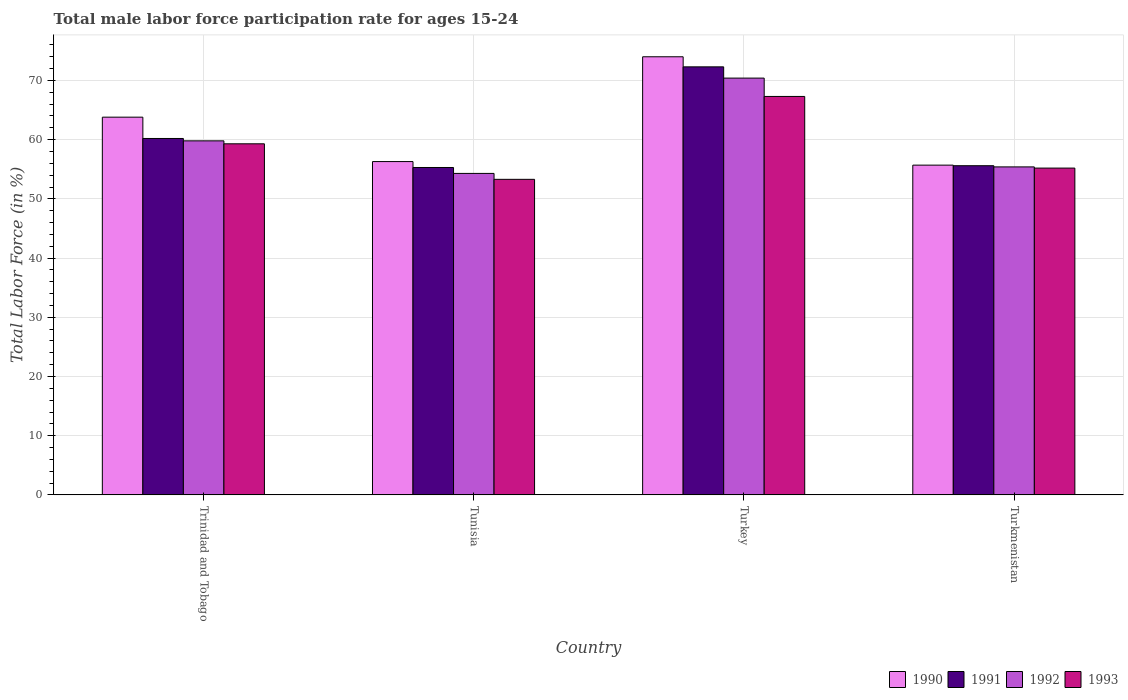How many different coloured bars are there?
Your answer should be compact. 4. How many groups of bars are there?
Your answer should be very brief. 4. Are the number of bars per tick equal to the number of legend labels?
Provide a succinct answer. Yes. How many bars are there on the 4th tick from the left?
Your response must be concise. 4. What is the label of the 1st group of bars from the left?
Ensure brevity in your answer.  Trinidad and Tobago. What is the male labor force participation rate in 1990 in Turkey?
Provide a succinct answer. 74. Across all countries, what is the maximum male labor force participation rate in 1992?
Keep it short and to the point. 70.4. Across all countries, what is the minimum male labor force participation rate in 1991?
Provide a succinct answer. 55.3. In which country was the male labor force participation rate in 1993 minimum?
Offer a terse response. Tunisia. What is the total male labor force participation rate in 1990 in the graph?
Provide a short and direct response. 249.8. What is the difference between the male labor force participation rate in 1991 in Turkey and that in Turkmenistan?
Provide a short and direct response. 16.7. What is the difference between the male labor force participation rate in 1990 in Turkey and the male labor force participation rate in 1993 in Trinidad and Tobago?
Provide a short and direct response. 14.7. What is the average male labor force participation rate in 1991 per country?
Provide a succinct answer. 60.85. What is the difference between the male labor force participation rate of/in 1991 and male labor force participation rate of/in 1993 in Turkey?
Your answer should be compact. 5. In how many countries, is the male labor force participation rate in 1992 greater than 72 %?
Keep it short and to the point. 0. What is the ratio of the male labor force participation rate in 1991 in Trinidad and Tobago to that in Turkmenistan?
Offer a terse response. 1.08. Is the difference between the male labor force participation rate in 1991 in Trinidad and Tobago and Tunisia greater than the difference between the male labor force participation rate in 1993 in Trinidad and Tobago and Tunisia?
Ensure brevity in your answer.  No. What is the difference between the highest and the second highest male labor force participation rate in 1993?
Ensure brevity in your answer.  -8. What is the difference between the highest and the lowest male labor force participation rate in 1990?
Your answer should be very brief. 18.3. In how many countries, is the male labor force participation rate in 1993 greater than the average male labor force participation rate in 1993 taken over all countries?
Give a very brief answer. 2. Is the sum of the male labor force participation rate in 1993 in Trinidad and Tobago and Turkmenistan greater than the maximum male labor force participation rate in 1991 across all countries?
Provide a succinct answer. Yes. What does the 1st bar from the left in Turkmenistan represents?
Your answer should be compact. 1990. Is it the case that in every country, the sum of the male labor force participation rate in 1991 and male labor force participation rate in 1990 is greater than the male labor force participation rate in 1992?
Your answer should be compact. Yes. Are all the bars in the graph horizontal?
Provide a short and direct response. No. Are the values on the major ticks of Y-axis written in scientific E-notation?
Provide a short and direct response. No. Does the graph contain grids?
Keep it short and to the point. Yes. How many legend labels are there?
Provide a succinct answer. 4. What is the title of the graph?
Your response must be concise. Total male labor force participation rate for ages 15-24. What is the label or title of the Y-axis?
Your answer should be very brief. Total Labor Force (in %). What is the Total Labor Force (in %) of 1990 in Trinidad and Tobago?
Keep it short and to the point. 63.8. What is the Total Labor Force (in %) of 1991 in Trinidad and Tobago?
Offer a terse response. 60.2. What is the Total Labor Force (in %) of 1992 in Trinidad and Tobago?
Make the answer very short. 59.8. What is the Total Labor Force (in %) in 1993 in Trinidad and Tobago?
Offer a terse response. 59.3. What is the Total Labor Force (in %) of 1990 in Tunisia?
Your response must be concise. 56.3. What is the Total Labor Force (in %) in 1991 in Tunisia?
Your answer should be compact. 55.3. What is the Total Labor Force (in %) of 1992 in Tunisia?
Make the answer very short. 54.3. What is the Total Labor Force (in %) in 1993 in Tunisia?
Ensure brevity in your answer.  53.3. What is the Total Labor Force (in %) of 1991 in Turkey?
Give a very brief answer. 72.3. What is the Total Labor Force (in %) in 1992 in Turkey?
Provide a succinct answer. 70.4. What is the Total Labor Force (in %) in 1993 in Turkey?
Ensure brevity in your answer.  67.3. What is the Total Labor Force (in %) in 1990 in Turkmenistan?
Offer a terse response. 55.7. What is the Total Labor Force (in %) of 1991 in Turkmenistan?
Offer a very short reply. 55.6. What is the Total Labor Force (in %) in 1992 in Turkmenistan?
Offer a very short reply. 55.4. What is the Total Labor Force (in %) in 1993 in Turkmenistan?
Make the answer very short. 55.2. Across all countries, what is the maximum Total Labor Force (in %) in 1991?
Provide a short and direct response. 72.3. Across all countries, what is the maximum Total Labor Force (in %) in 1992?
Ensure brevity in your answer.  70.4. Across all countries, what is the maximum Total Labor Force (in %) in 1993?
Provide a short and direct response. 67.3. Across all countries, what is the minimum Total Labor Force (in %) of 1990?
Give a very brief answer. 55.7. Across all countries, what is the minimum Total Labor Force (in %) in 1991?
Give a very brief answer. 55.3. Across all countries, what is the minimum Total Labor Force (in %) of 1992?
Offer a very short reply. 54.3. Across all countries, what is the minimum Total Labor Force (in %) of 1993?
Offer a very short reply. 53.3. What is the total Total Labor Force (in %) in 1990 in the graph?
Give a very brief answer. 249.8. What is the total Total Labor Force (in %) of 1991 in the graph?
Make the answer very short. 243.4. What is the total Total Labor Force (in %) in 1992 in the graph?
Ensure brevity in your answer.  239.9. What is the total Total Labor Force (in %) in 1993 in the graph?
Ensure brevity in your answer.  235.1. What is the difference between the Total Labor Force (in %) in 1993 in Trinidad and Tobago and that in Tunisia?
Provide a succinct answer. 6. What is the difference between the Total Labor Force (in %) of 1990 in Trinidad and Tobago and that in Turkey?
Keep it short and to the point. -10.2. What is the difference between the Total Labor Force (in %) of 1991 in Trinidad and Tobago and that in Turkey?
Your answer should be compact. -12.1. What is the difference between the Total Labor Force (in %) of 1993 in Trinidad and Tobago and that in Turkey?
Keep it short and to the point. -8. What is the difference between the Total Labor Force (in %) in 1990 in Trinidad and Tobago and that in Turkmenistan?
Make the answer very short. 8.1. What is the difference between the Total Labor Force (in %) in 1991 in Trinidad and Tobago and that in Turkmenistan?
Make the answer very short. 4.6. What is the difference between the Total Labor Force (in %) of 1992 in Trinidad and Tobago and that in Turkmenistan?
Give a very brief answer. 4.4. What is the difference between the Total Labor Force (in %) in 1990 in Tunisia and that in Turkey?
Your answer should be compact. -17.7. What is the difference between the Total Labor Force (in %) in 1992 in Tunisia and that in Turkey?
Your answer should be very brief. -16.1. What is the difference between the Total Labor Force (in %) in 1993 in Tunisia and that in Turkey?
Your answer should be very brief. -14. What is the difference between the Total Labor Force (in %) of 1992 in Tunisia and that in Turkmenistan?
Provide a short and direct response. -1.1. What is the difference between the Total Labor Force (in %) of 1990 in Turkey and that in Turkmenistan?
Your answer should be very brief. 18.3. What is the difference between the Total Labor Force (in %) of 1991 in Turkey and that in Turkmenistan?
Provide a succinct answer. 16.7. What is the difference between the Total Labor Force (in %) of 1992 in Turkey and that in Turkmenistan?
Make the answer very short. 15. What is the difference between the Total Labor Force (in %) in 1990 in Trinidad and Tobago and the Total Labor Force (in %) in 1993 in Tunisia?
Provide a succinct answer. 10.5. What is the difference between the Total Labor Force (in %) in 1990 in Trinidad and Tobago and the Total Labor Force (in %) in 1992 in Turkey?
Provide a succinct answer. -6.6. What is the difference between the Total Labor Force (in %) of 1991 in Trinidad and Tobago and the Total Labor Force (in %) of 1992 in Turkey?
Provide a succinct answer. -10.2. What is the difference between the Total Labor Force (in %) in 1991 in Trinidad and Tobago and the Total Labor Force (in %) in 1993 in Turkey?
Keep it short and to the point. -7.1. What is the difference between the Total Labor Force (in %) in 1992 in Trinidad and Tobago and the Total Labor Force (in %) in 1993 in Turkey?
Offer a very short reply. -7.5. What is the difference between the Total Labor Force (in %) in 1990 in Trinidad and Tobago and the Total Labor Force (in %) in 1992 in Turkmenistan?
Provide a succinct answer. 8.4. What is the difference between the Total Labor Force (in %) of 1990 in Trinidad and Tobago and the Total Labor Force (in %) of 1993 in Turkmenistan?
Make the answer very short. 8.6. What is the difference between the Total Labor Force (in %) of 1991 in Trinidad and Tobago and the Total Labor Force (in %) of 1993 in Turkmenistan?
Your answer should be compact. 5. What is the difference between the Total Labor Force (in %) in 1992 in Trinidad and Tobago and the Total Labor Force (in %) in 1993 in Turkmenistan?
Your response must be concise. 4.6. What is the difference between the Total Labor Force (in %) in 1990 in Tunisia and the Total Labor Force (in %) in 1992 in Turkey?
Your answer should be compact. -14.1. What is the difference between the Total Labor Force (in %) of 1990 in Tunisia and the Total Labor Force (in %) of 1993 in Turkey?
Offer a very short reply. -11. What is the difference between the Total Labor Force (in %) of 1991 in Tunisia and the Total Labor Force (in %) of 1992 in Turkey?
Offer a terse response. -15.1. What is the difference between the Total Labor Force (in %) of 1991 in Tunisia and the Total Labor Force (in %) of 1993 in Turkey?
Offer a terse response. -12. What is the difference between the Total Labor Force (in %) in 1992 in Tunisia and the Total Labor Force (in %) in 1993 in Turkey?
Give a very brief answer. -13. What is the difference between the Total Labor Force (in %) in 1991 in Tunisia and the Total Labor Force (in %) in 1992 in Turkmenistan?
Ensure brevity in your answer.  -0.1. What is the difference between the Total Labor Force (in %) in 1990 in Turkey and the Total Labor Force (in %) in 1992 in Turkmenistan?
Make the answer very short. 18.6. What is the difference between the Total Labor Force (in %) of 1990 in Turkey and the Total Labor Force (in %) of 1993 in Turkmenistan?
Make the answer very short. 18.8. What is the difference between the Total Labor Force (in %) of 1991 in Turkey and the Total Labor Force (in %) of 1992 in Turkmenistan?
Provide a short and direct response. 16.9. What is the difference between the Total Labor Force (in %) in 1991 in Turkey and the Total Labor Force (in %) in 1993 in Turkmenistan?
Give a very brief answer. 17.1. What is the average Total Labor Force (in %) in 1990 per country?
Offer a very short reply. 62.45. What is the average Total Labor Force (in %) in 1991 per country?
Your response must be concise. 60.85. What is the average Total Labor Force (in %) in 1992 per country?
Your response must be concise. 59.98. What is the average Total Labor Force (in %) in 1993 per country?
Provide a short and direct response. 58.77. What is the difference between the Total Labor Force (in %) in 1990 and Total Labor Force (in %) in 1991 in Trinidad and Tobago?
Provide a short and direct response. 3.6. What is the difference between the Total Labor Force (in %) of 1990 and Total Labor Force (in %) of 1992 in Trinidad and Tobago?
Offer a very short reply. 4. What is the difference between the Total Labor Force (in %) of 1991 and Total Labor Force (in %) of 1992 in Trinidad and Tobago?
Offer a terse response. 0.4. What is the difference between the Total Labor Force (in %) in 1990 and Total Labor Force (in %) in 1991 in Tunisia?
Provide a short and direct response. 1. What is the difference between the Total Labor Force (in %) of 1990 and Total Labor Force (in %) of 1993 in Tunisia?
Your answer should be very brief. 3. What is the difference between the Total Labor Force (in %) of 1991 and Total Labor Force (in %) of 1993 in Tunisia?
Offer a terse response. 2. What is the difference between the Total Labor Force (in %) in 1992 and Total Labor Force (in %) in 1993 in Tunisia?
Provide a short and direct response. 1. What is the difference between the Total Labor Force (in %) in 1990 and Total Labor Force (in %) in 1991 in Turkey?
Your response must be concise. 1.7. What is the difference between the Total Labor Force (in %) of 1990 and Total Labor Force (in %) of 1992 in Turkey?
Ensure brevity in your answer.  3.6. What is the difference between the Total Labor Force (in %) of 1990 and Total Labor Force (in %) of 1993 in Turkey?
Give a very brief answer. 6.7. What is the difference between the Total Labor Force (in %) of 1991 and Total Labor Force (in %) of 1993 in Turkey?
Keep it short and to the point. 5. What is the difference between the Total Labor Force (in %) in 1992 and Total Labor Force (in %) in 1993 in Turkey?
Keep it short and to the point. 3.1. What is the difference between the Total Labor Force (in %) in 1990 and Total Labor Force (in %) in 1991 in Turkmenistan?
Your answer should be compact. 0.1. What is the difference between the Total Labor Force (in %) in 1991 and Total Labor Force (in %) in 1992 in Turkmenistan?
Ensure brevity in your answer.  0.2. What is the difference between the Total Labor Force (in %) of 1992 and Total Labor Force (in %) of 1993 in Turkmenistan?
Ensure brevity in your answer.  0.2. What is the ratio of the Total Labor Force (in %) of 1990 in Trinidad and Tobago to that in Tunisia?
Your answer should be very brief. 1.13. What is the ratio of the Total Labor Force (in %) of 1991 in Trinidad and Tobago to that in Tunisia?
Ensure brevity in your answer.  1.09. What is the ratio of the Total Labor Force (in %) in 1992 in Trinidad and Tobago to that in Tunisia?
Give a very brief answer. 1.1. What is the ratio of the Total Labor Force (in %) in 1993 in Trinidad and Tobago to that in Tunisia?
Keep it short and to the point. 1.11. What is the ratio of the Total Labor Force (in %) in 1990 in Trinidad and Tobago to that in Turkey?
Keep it short and to the point. 0.86. What is the ratio of the Total Labor Force (in %) in 1991 in Trinidad and Tobago to that in Turkey?
Your answer should be very brief. 0.83. What is the ratio of the Total Labor Force (in %) in 1992 in Trinidad and Tobago to that in Turkey?
Provide a short and direct response. 0.85. What is the ratio of the Total Labor Force (in %) of 1993 in Trinidad and Tobago to that in Turkey?
Your answer should be very brief. 0.88. What is the ratio of the Total Labor Force (in %) of 1990 in Trinidad and Tobago to that in Turkmenistan?
Offer a very short reply. 1.15. What is the ratio of the Total Labor Force (in %) of 1991 in Trinidad and Tobago to that in Turkmenistan?
Your answer should be compact. 1.08. What is the ratio of the Total Labor Force (in %) in 1992 in Trinidad and Tobago to that in Turkmenistan?
Keep it short and to the point. 1.08. What is the ratio of the Total Labor Force (in %) of 1993 in Trinidad and Tobago to that in Turkmenistan?
Your response must be concise. 1.07. What is the ratio of the Total Labor Force (in %) in 1990 in Tunisia to that in Turkey?
Keep it short and to the point. 0.76. What is the ratio of the Total Labor Force (in %) of 1991 in Tunisia to that in Turkey?
Make the answer very short. 0.76. What is the ratio of the Total Labor Force (in %) in 1992 in Tunisia to that in Turkey?
Make the answer very short. 0.77. What is the ratio of the Total Labor Force (in %) in 1993 in Tunisia to that in Turkey?
Offer a terse response. 0.79. What is the ratio of the Total Labor Force (in %) in 1990 in Tunisia to that in Turkmenistan?
Keep it short and to the point. 1.01. What is the ratio of the Total Labor Force (in %) in 1991 in Tunisia to that in Turkmenistan?
Make the answer very short. 0.99. What is the ratio of the Total Labor Force (in %) of 1992 in Tunisia to that in Turkmenistan?
Ensure brevity in your answer.  0.98. What is the ratio of the Total Labor Force (in %) in 1993 in Tunisia to that in Turkmenistan?
Offer a terse response. 0.97. What is the ratio of the Total Labor Force (in %) in 1990 in Turkey to that in Turkmenistan?
Provide a short and direct response. 1.33. What is the ratio of the Total Labor Force (in %) in 1991 in Turkey to that in Turkmenistan?
Your response must be concise. 1.3. What is the ratio of the Total Labor Force (in %) in 1992 in Turkey to that in Turkmenistan?
Your answer should be very brief. 1.27. What is the ratio of the Total Labor Force (in %) in 1993 in Turkey to that in Turkmenistan?
Your response must be concise. 1.22. What is the difference between the highest and the second highest Total Labor Force (in %) in 1990?
Provide a succinct answer. 10.2. What is the difference between the highest and the second highest Total Labor Force (in %) in 1992?
Offer a very short reply. 10.6. What is the difference between the highest and the lowest Total Labor Force (in %) in 1990?
Provide a short and direct response. 18.3. What is the difference between the highest and the lowest Total Labor Force (in %) in 1991?
Offer a terse response. 17. What is the difference between the highest and the lowest Total Labor Force (in %) in 1993?
Your response must be concise. 14. 